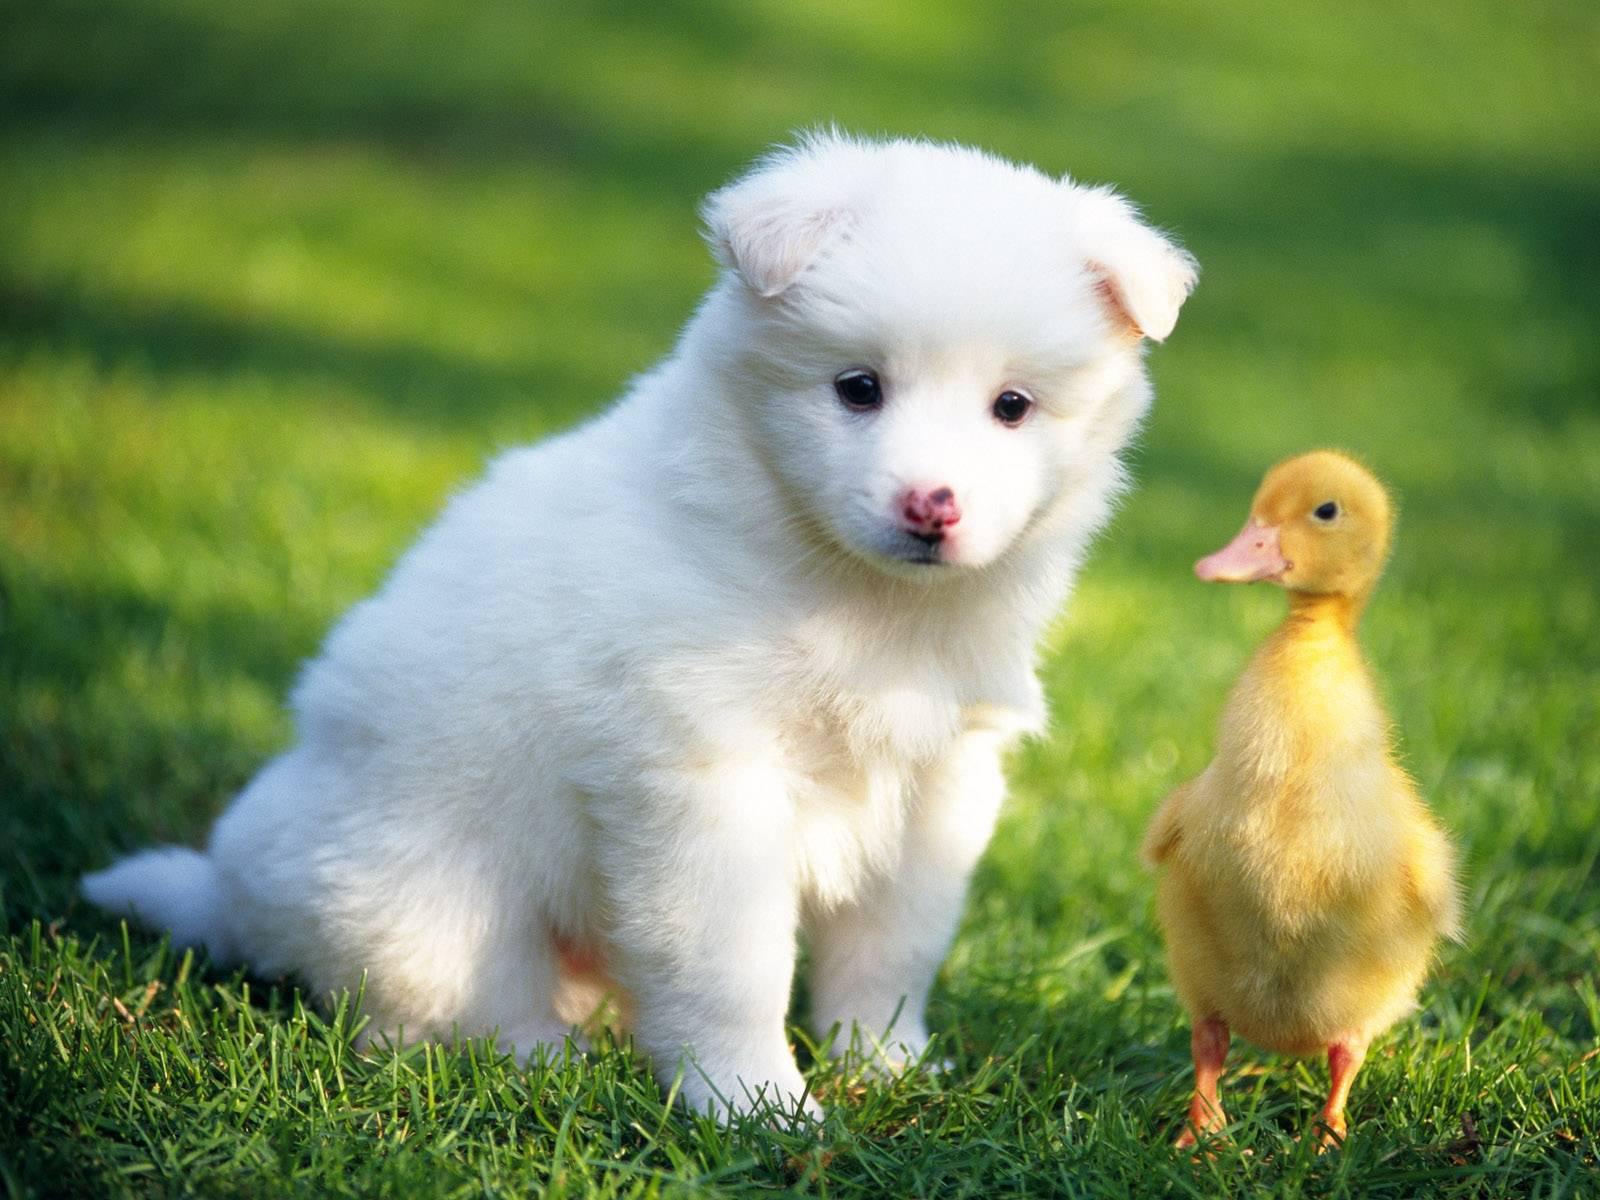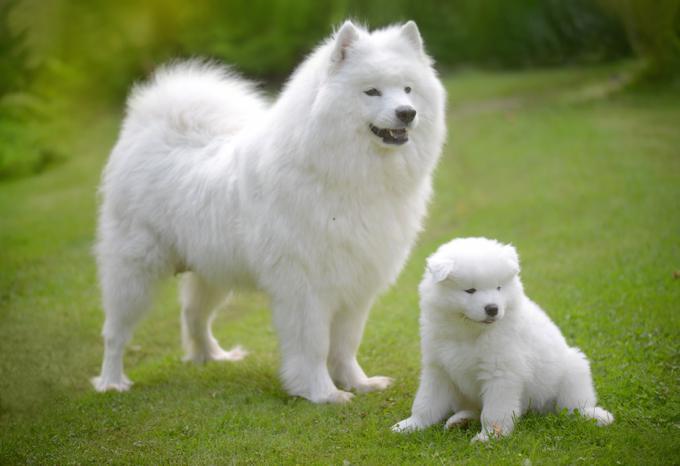The first image is the image on the left, the second image is the image on the right. For the images shown, is this caption "There are two dogs in the image on the left." true? Answer yes or no. No. The first image is the image on the left, the second image is the image on the right. For the images displayed, is the sentence "Combined, the images contain exactly four animals." factually correct? Answer yes or no. Yes. 